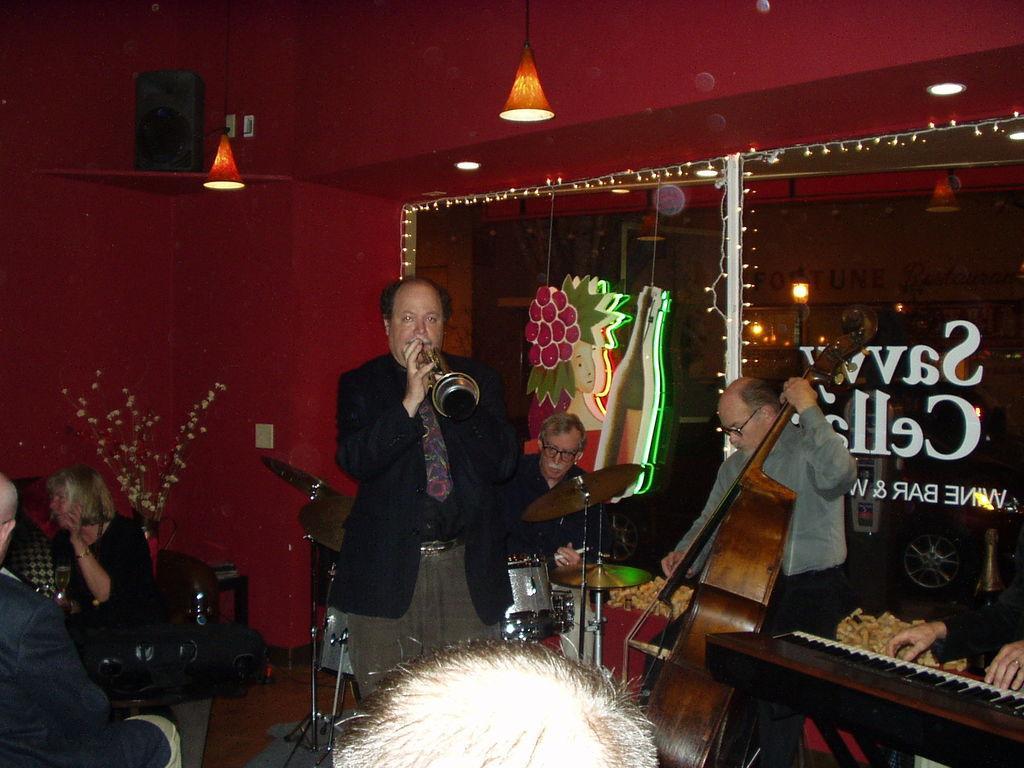How would you summarize this image in a sentence or two? The picture is taken inside a room. There few old people are playing musical instruments. In the left two people are sitting on chairs. In the middle there is a table. In the top there are lights. In the back there is a glass wall. Here is a speaker. 